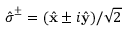Convert formula to latex. <formula><loc_0><loc_0><loc_500><loc_500>\hat { \sigma } ^ { \pm } = ( \hat { x } \pm i \hat { y } ) / \sqrt { 2 }</formula> 